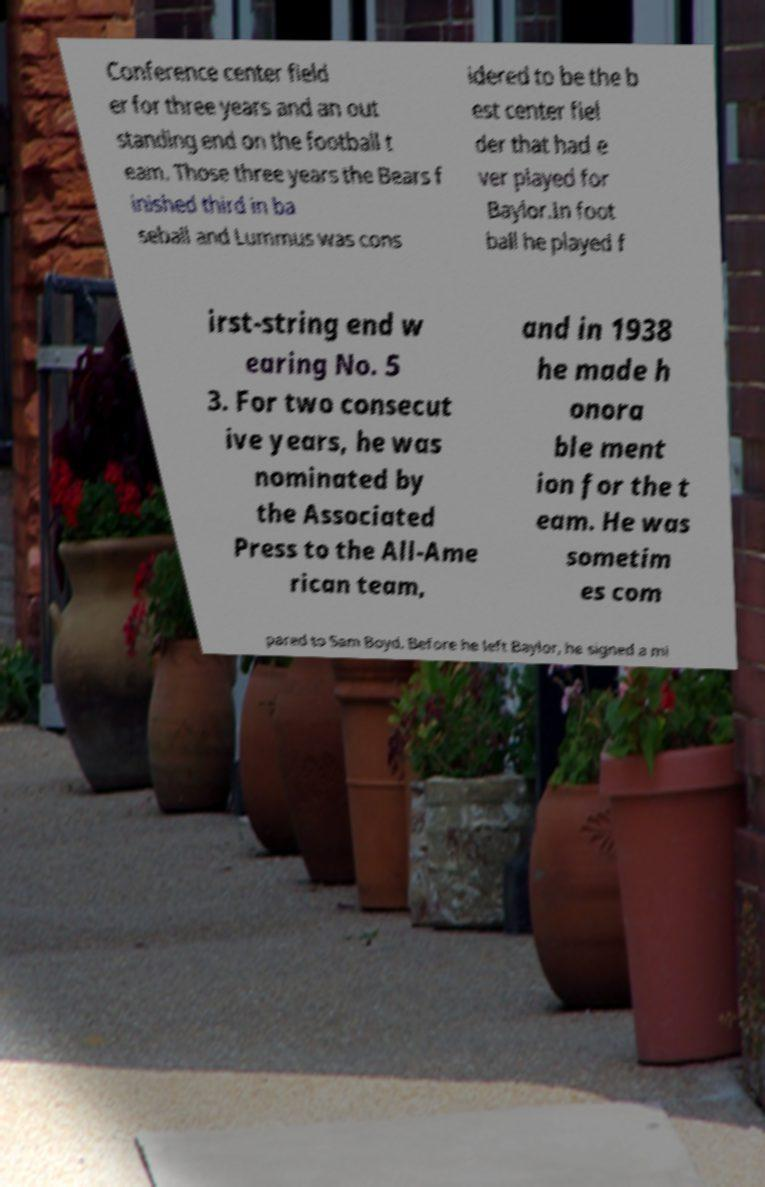What messages or text are displayed in this image? I need them in a readable, typed format. Conference center field er for three years and an out standing end on the football t eam. Those three years the Bears f inished third in ba seball and Lummus was cons idered to be the b est center fiel der that had e ver played for Baylor.In foot ball he played f irst-string end w earing No. 5 3. For two consecut ive years, he was nominated by the Associated Press to the All-Ame rican team, and in 1938 he made h onora ble ment ion for the t eam. He was sometim es com pared to Sam Boyd. Before he left Baylor, he signed a mi 